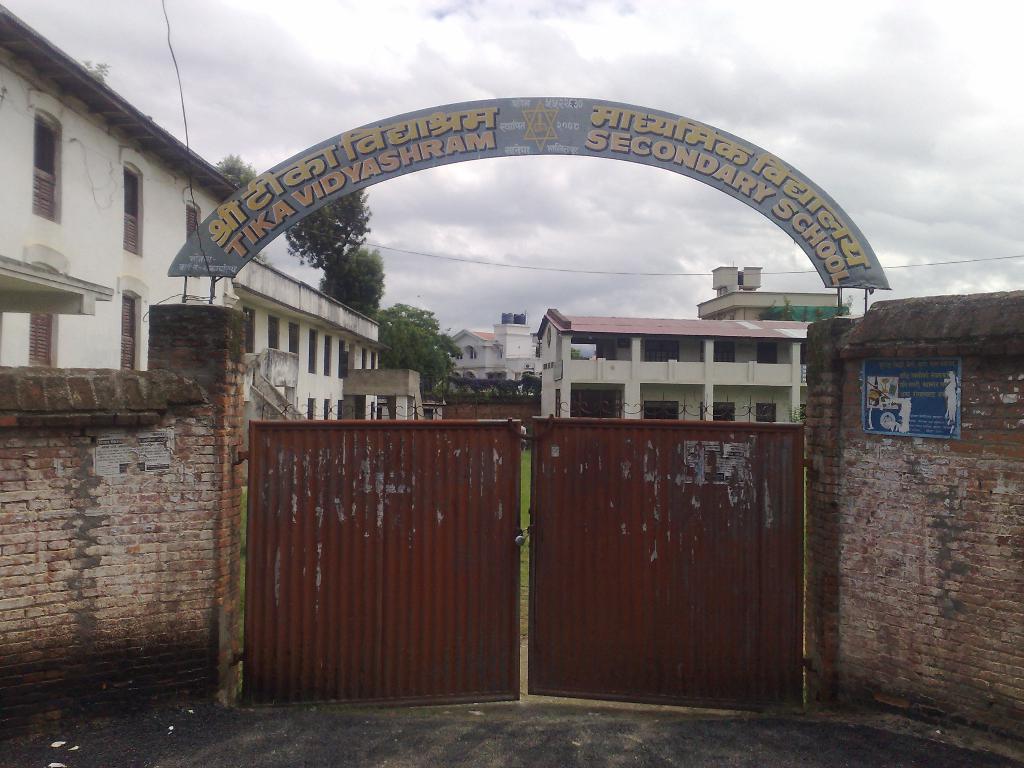Can you describe this image briefly? At the top of the picture we can see clouds and it seem like a cloudy day. This is a gate in brown colour. Here we can see a wall with bricks. This is an arch starting a school name. Inside the gate we can see buildings. These are trees. We can see water tanks at the top of the building. 